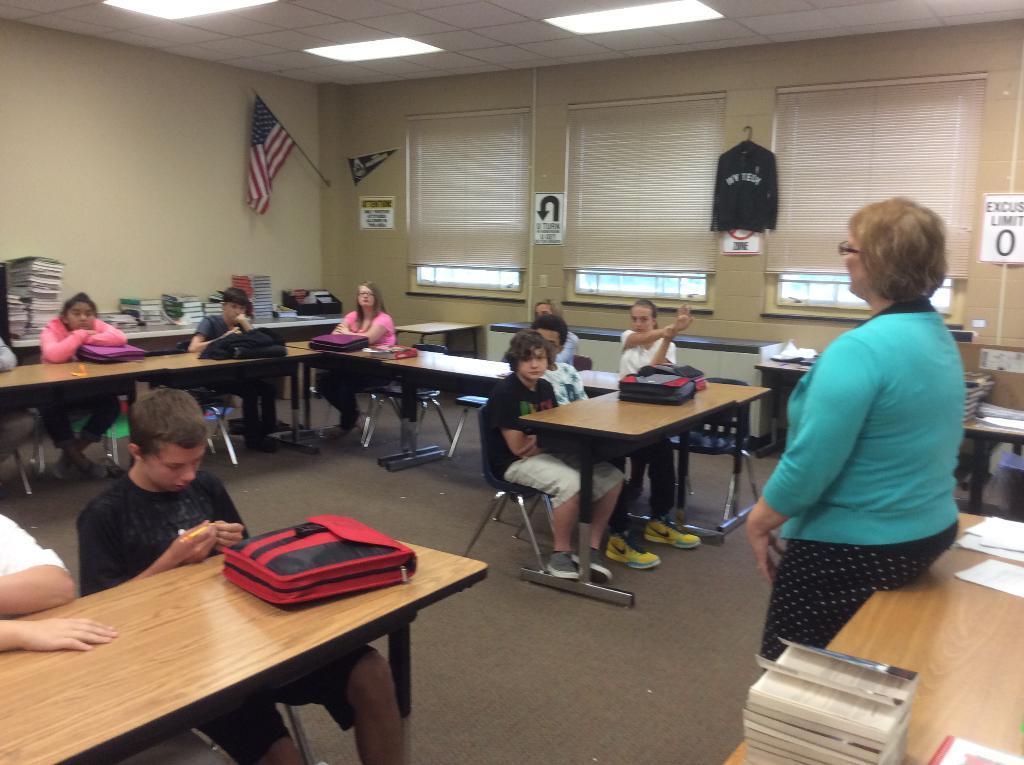Describe this image in one or two sentences. This image is clicked in a room where in the middle there are Windows and window Blinds and a flag. There are lights on the top. There are benches and chairs. Children are sitting on chairs and on the table there are bags, books, papers. Back side there is a table on which all the books are placed. 